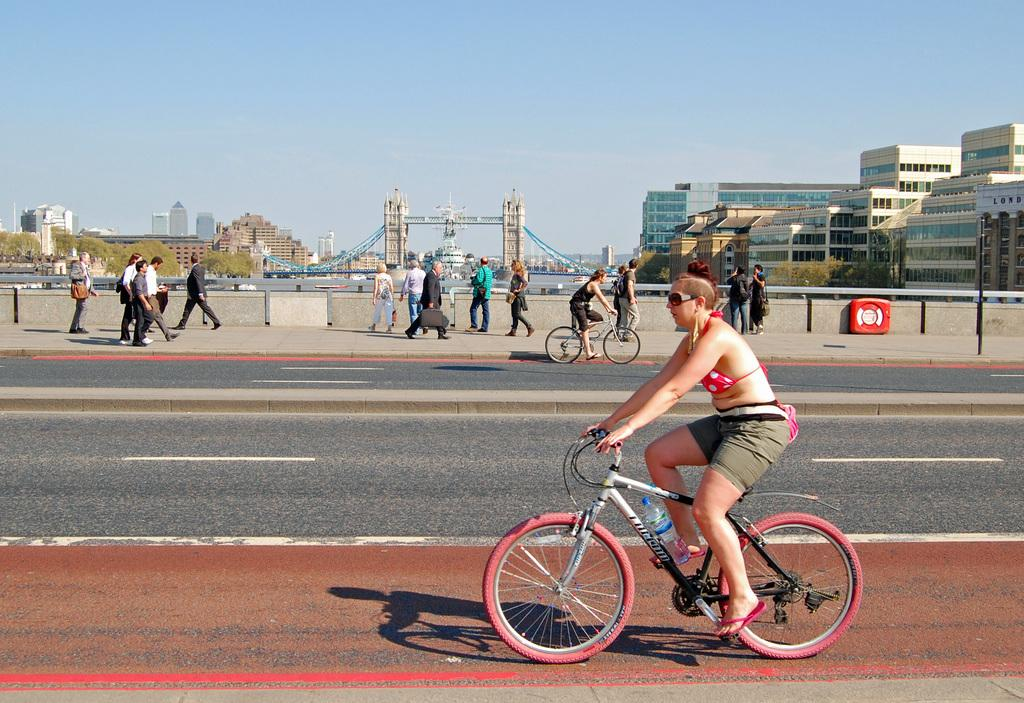What are the women in the image doing? The women in the image are riding bicycles on the road. Are there any other people in the image? Yes, there are people walking behind the women. What can be seen in the background of the image? Buildings, trees, water, and the sky are visible in the background. What time of day is it in the image, and what is the brain doing? The time of day cannot be determined from the image, and there is no brain present in the image. 